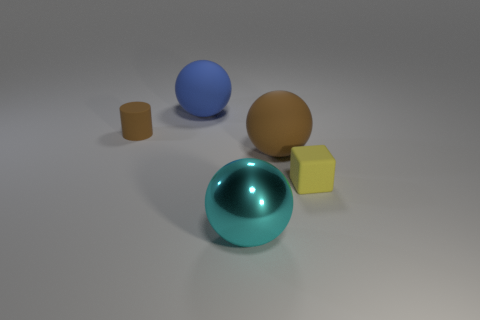Is there any other thing that has the same color as the matte cylinder?
Provide a short and direct response. Yes. What is the shape of the tiny brown thing that is made of the same material as the yellow thing?
Your response must be concise. Cylinder. Is the size of the yellow block the same as the blue rubber sphere?
Ensure brevity in your answer.  No. Is the material of the large ball behind the tiny brown rubber object the same as the small brown cylinder?
Your answer should be very brief. Yes. Is there anything else that is made of the same material as the large cyan object?
Offer a very short reply. No. There is a brown matte object right of the large thing behind the cylinder; how many large brown rubber spheres are behind it?
Offer a very short reply. 0. Does the large object that is on the left side of the cyan object have the same shape as the yellow thing?
Ensure brevity in your answer.  No. What number of things are big metal balls or tiny rubber things behind the tiny yellow rubber block?
Your answer should be very brief. 2. Is the number of tiny matte cylinders in front of the large cyan thing greater than the number of metal objects?
Provide a succinct answer. No. Are there the same number of blue things in front of the small cube and cyan metallic things that are in front of the large brown rubber thing?
Your answer should be compact. No. 